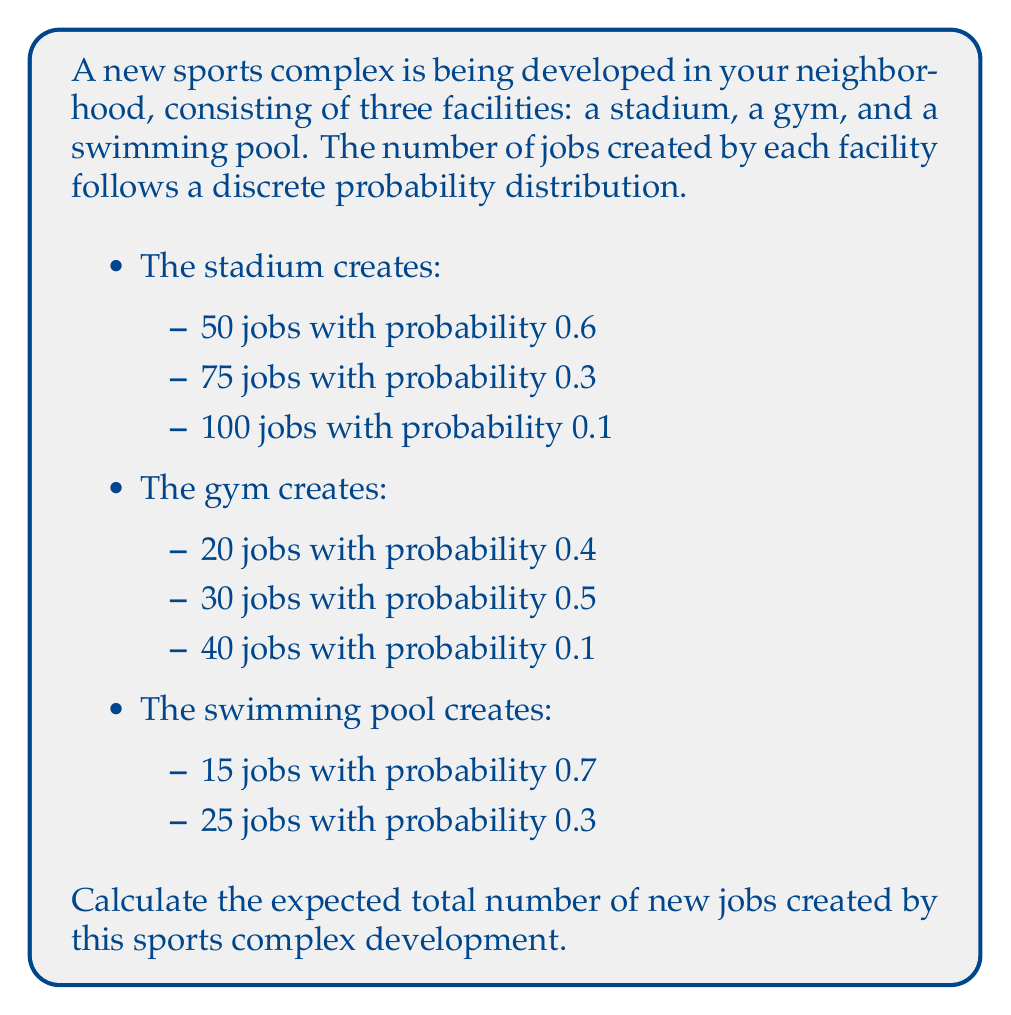Teach me how to tackle this problem. To solve this problem, we need to calculate the expected value for each facility and then sum them up:

1. For the stadium:
   $E(X_{stadium}) = 50 \cdot 0.6 + 75 \cdot 0.3 + 100 \cdot 0.1$
   $E(X_{stadium}) = 30 + 22.5 + 10 = 62.5$ jobs

2. For the gym:
   $E(X_{gym}) = 20 \cdot 0.4 + 30 \cdot 0.5 + 40 \cdot 0.1$
   $E(X_{gym}) = 8 + 15 + 4 = 27$ jobs

3. For the swimming pool:
   $E(X_{pool}) = 15 \cdot 0.7 + 25 \cdot 0.3$
   $E(X_{pool}) = 10.5 + 7.5 = 18$ jobs

4. Total expected number of jobs:
   $E(X_{total}) = E(X_{stadium}) + E(X_{gym}) + E(X_{pool})$
   $E(X_{total}) = 62.5 + 27 + 18 = 107.5$ jobs

Therefore, the expected total number of new jobs created by the sports complex development is 107.5 jobs.
Answer: 107.5 jobs 